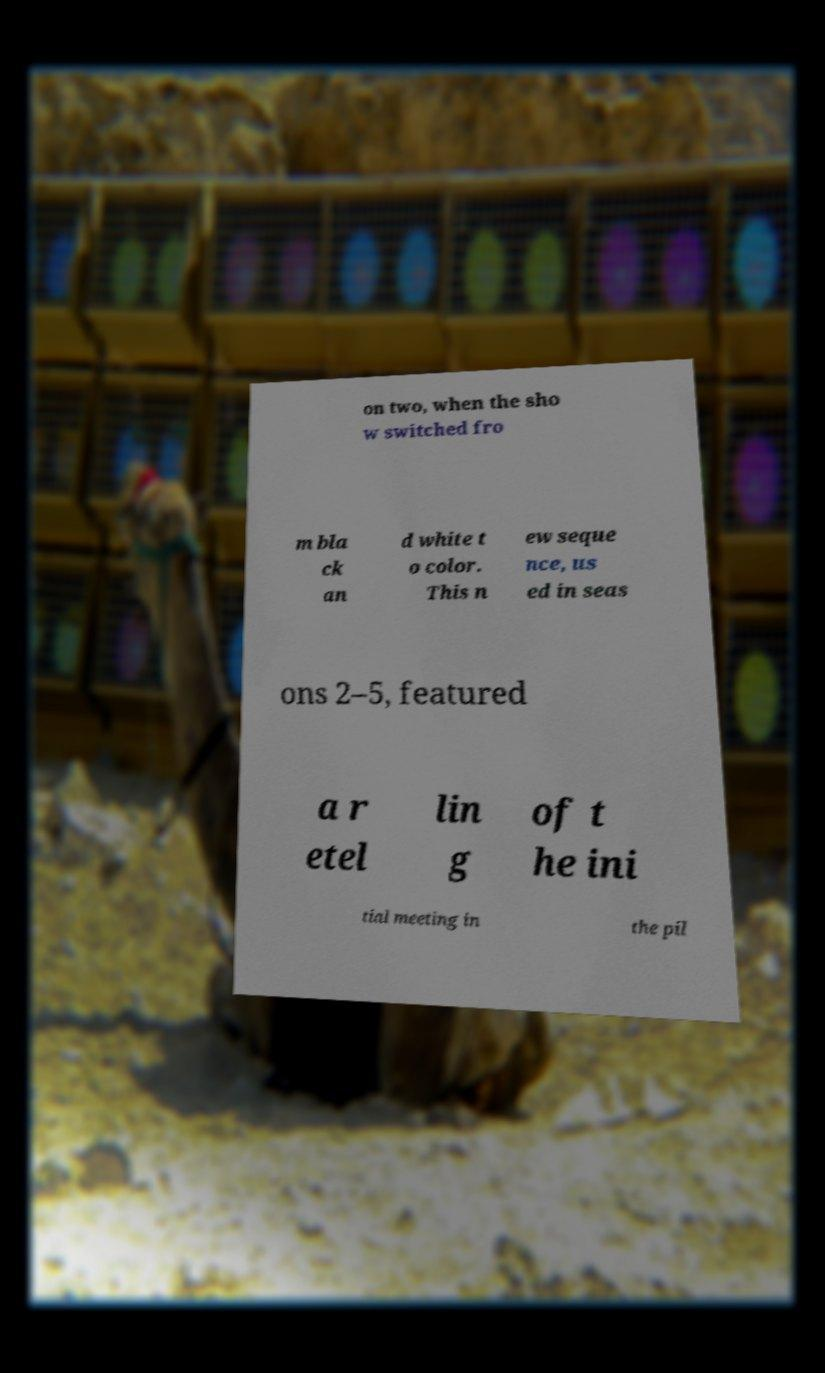I need the written content from this picture converted into text. Can you do that? on two, when the sho w switched fro m bla ck an d white t o color. This n ew seque nce, us ed in seas ons 2–5, featured a r etel lin g of t he ini tial meeting in the pil 